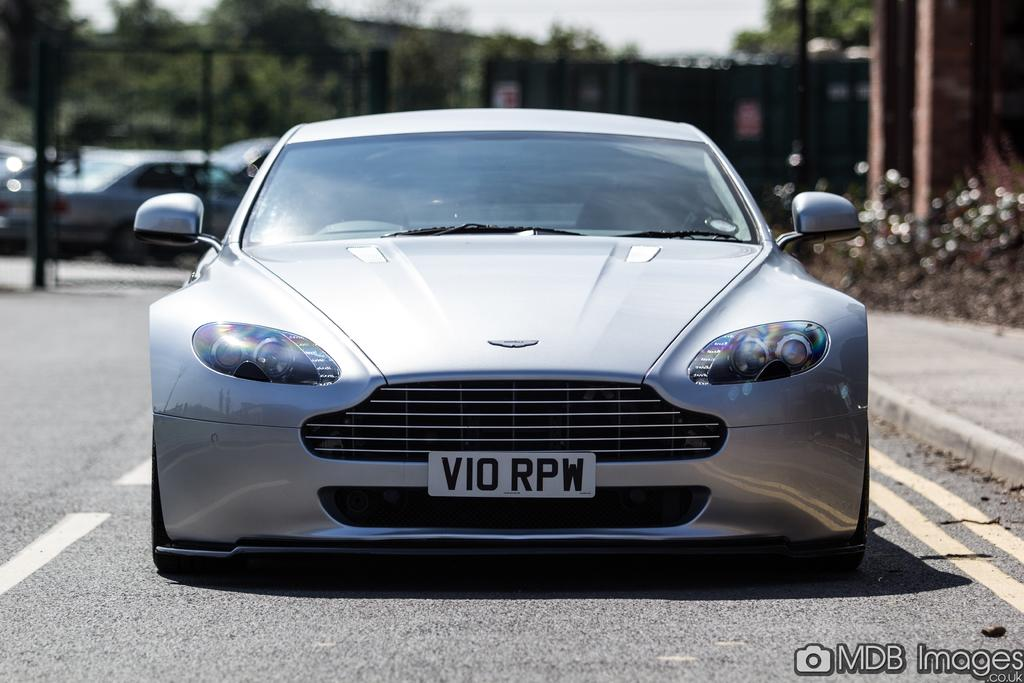What is the main subject of the image? The main subject of the image is a car on the road. What is located beside the car? There is a footpath beside the car. What can be seen on the left side of the image? Plants and poles are present on the left side of the image. What is visible in the background of the image? There are other cars on the road in the background. What reward is the car receiving for being on the road in the image? There is no reward being given to the car in the image; it is simply parked on the road. What type of bucket can be seen in the image? There is no bucket present in the image. 